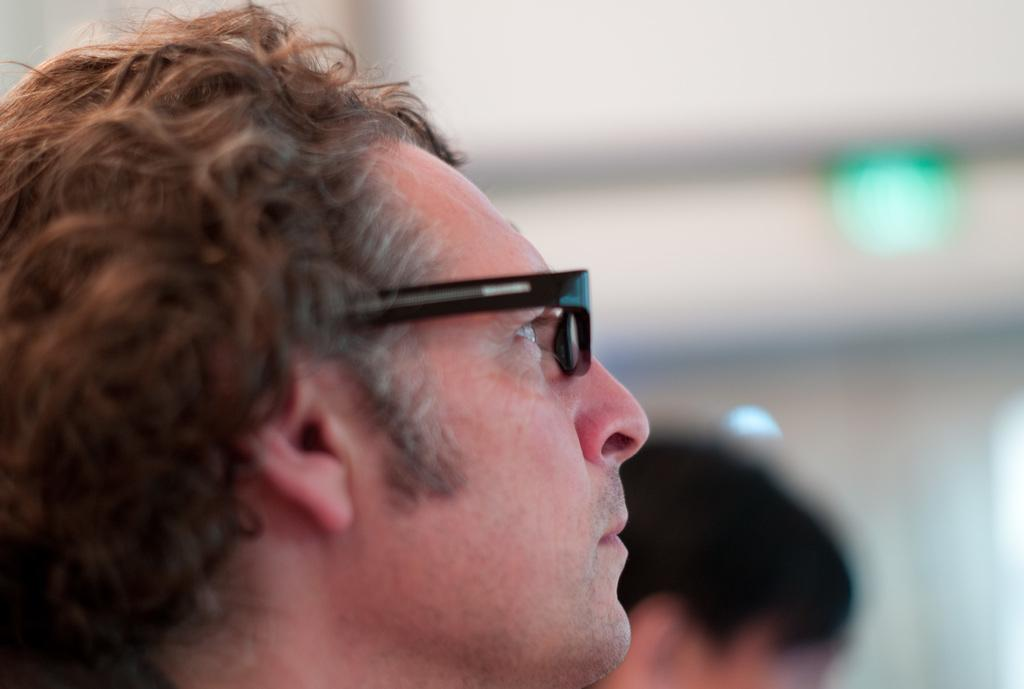How many people are in the image? There are two men in the image. Can you describe the quality of the image? The image is blurred. What type of balls can be seen in the image? There are no balls present in the image. What hope does the image convey? The image does not convey any specific hope, as it is blurred and only features two men. 